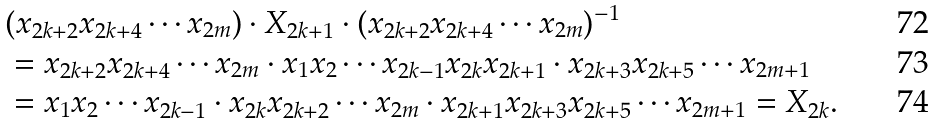Convert formula to latex. <formula><loc_0><loc_0><loc_500><loc_500>& ( x _ { 2 k + 2 } x _ { 2 k + 4 } \cdots x _ { 2 m } ) \cdot X _ { 2 k + 1 } \cdot ( x _ { 2 k + 2 } x _ { 2 k + 4 } \cdots x _ { 2 m } ) ^ { - 1 } \\ & = x _ { 2 k + 2 } x _ { 2 k + 4 } \cdots x _ { 2 m } \cdot x _ { 1 } x _ { 2 } \cdots x _ { 2 k - 1 } x _ { 2 k } x _ { 2 k + 1 } \cdot x _ { 2 k + 3 } x _ { 2 k + 5 } \cdots x _ { 2 m + 1 } \\ & = x _ { 1 } x _ { 2 } \cdots x _ { 2 k - 1 } \cdot x _ { 2 k } x _ { 2 k + 2 } \cdots x _ { 2 m } \cdot x _ { 2 k + 1 } x _ { 2 k + 3 } x _ { 2 k + 5 } \cdots x _ { 2 m + 1 } = X _ { 2 k } .</formula> 